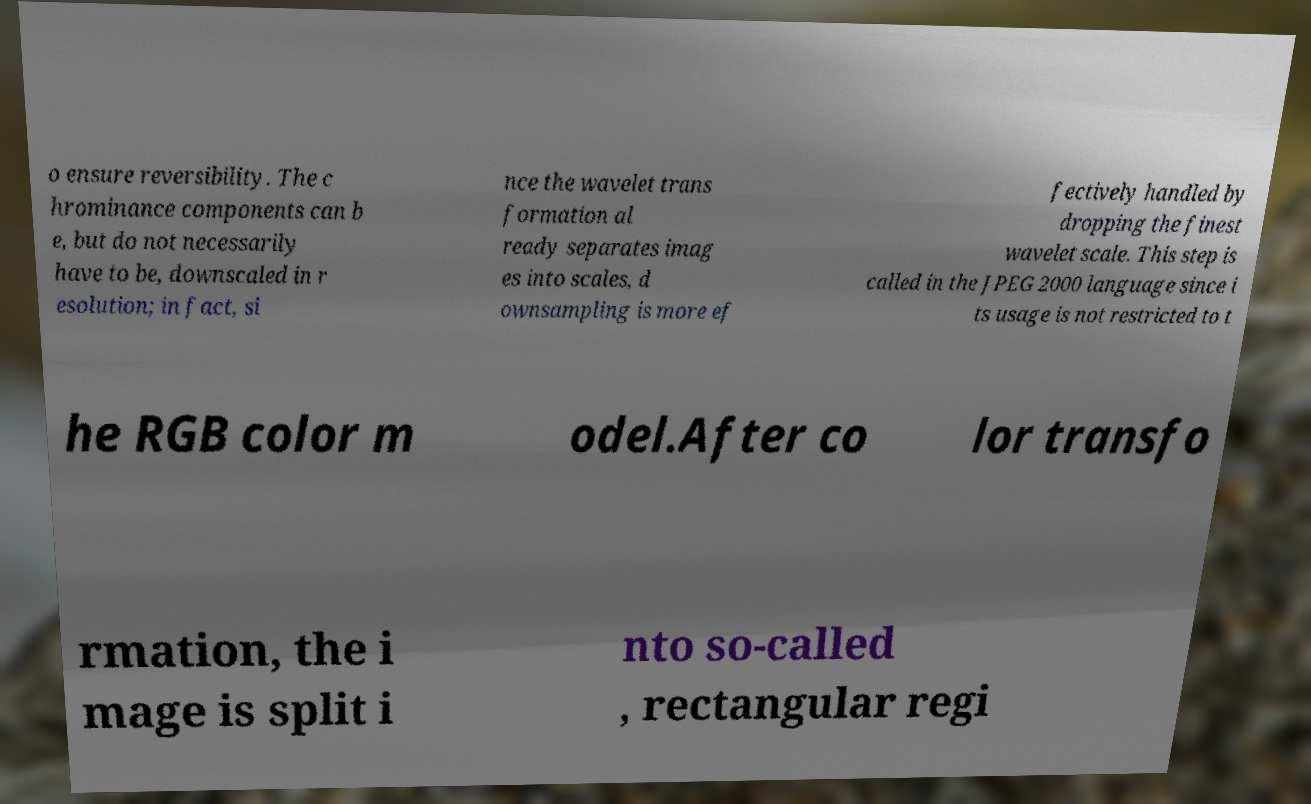Could you extract and type out the text from this image? o ensure reversibility. The c hrominance components can b e, but do not necessarily have to be, downscaled in r esolution; in fact, si nce the wavelet trans formation al ready separates imag es into scales, d ownsampling is more ef fectively handled by dropping the finest wavelet scale. This step is called in the JPEG 2000 language since i ts usage is not restricted to t he RGB color m odel.After co lor transfo rmation, the i mage is split i nto so-called , rectangular regi 